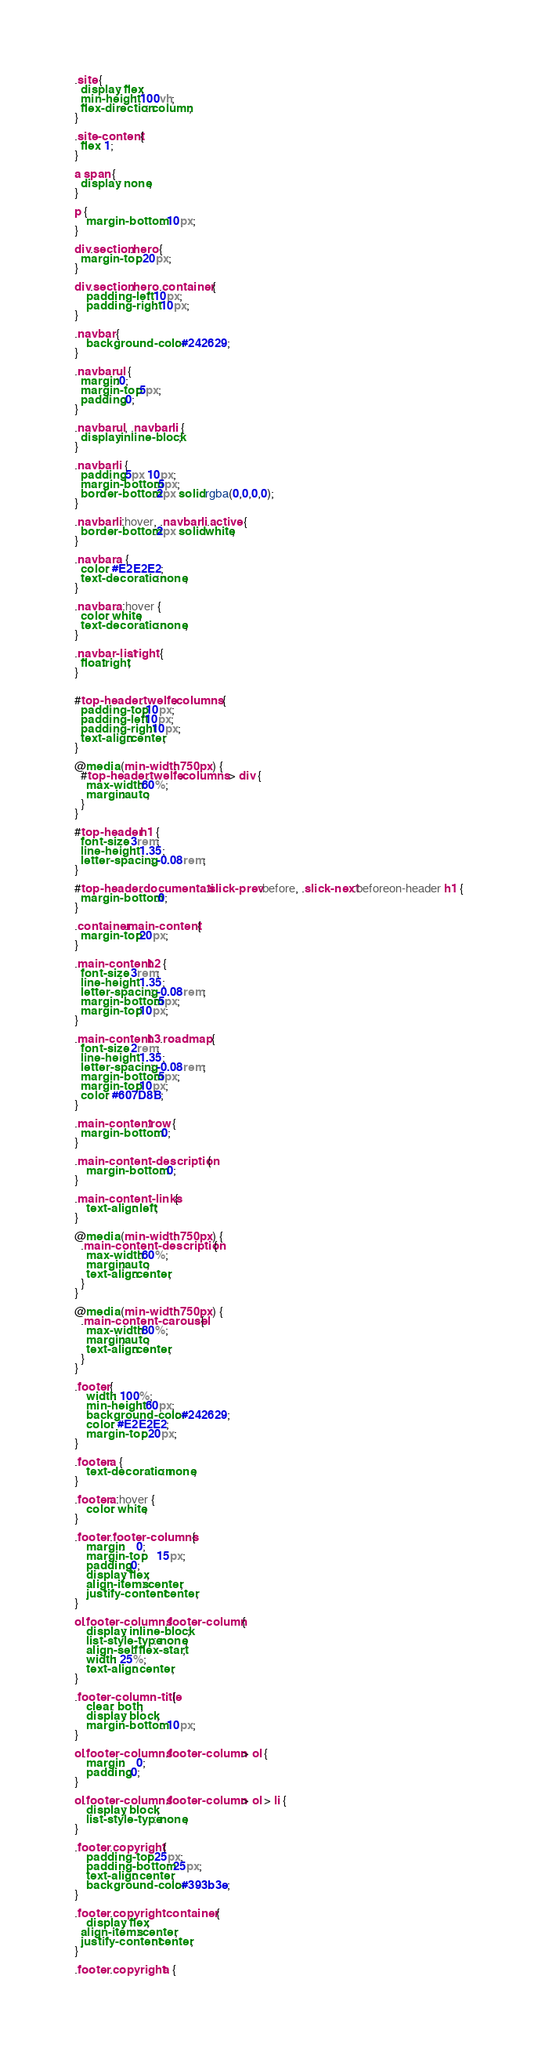<code> <loc_0><loc_0><loc_500><loc_500><_CSS_>.site {
  display: flex;
  min-height: 100vh;
  flex-direction: column;
}

.site-content {
  flex: 1;
}

a span {
  display: none;
}

p {
	margin-bottom: 10px;
}

div.section.hero {
  margin-top: 20px;
}

div.section.hero .container {
	padding-left: 10px;
	padding-right: 10px;
}

.navbar {
	background-color: #242629;
}

.navbar ul {
  margin:0;
  margin-top:5px;
  padding:0;
}

.navbar ul, .navbar li {
  display:inline-block;
}

.navbar li {
  padding:5px 10px;
  margin-bottom:5px;
  border-bottom:2px solid rgba(0,0,0,0);
}

.navbar li:hover, .navbar li.active {
  border-bottom:2px solid white;
}

.navbar a {
  color: #E2E2E2;
  text-decoration:none;
}

.navbar a:hover {
  color: white;
  text-decoration:none;
}

.navbar-list.right {
  float:right;
}


#top-header .twelfe.columns {
  padding-top:10px;
  padding-left:10px;
  padding-right:10px;
  text-align:center;
}

@media (min-width: 750px) {
  #top-header .twelfe.columns > div {
    max-width:60%;
    margin:auto;
  }
}

#top-header h1 {
  font-size: 3rem;
  line-height: 1.35;
  letter-spacing: -0.08rem;
}

#top-header .documentati.slick-prev:before, .slick-next:beforeon-header h1 {
  margin-bottom:0;
}

.container.main-content {
  margin-top:20px;
}

.main-content h2 {
  font-size: 3rem;
  line-height: 1.35;
  letter-spacing: -0.08rem;
  margin-bottom:5px;
  margin-top:10px;
}

.main-content h3.roadmap {
  font-size: 2rem;
  line-height: 1.35;
  letter-spacing: -0.08rem;
  margin-bottom:5px;
  margin-top:10px;
  color: #607D8B;
}

.main-content .row {
  margin-bottom: 0;
}

.main-content-description {
	margin-bottom: 0;
}

.main-content-links {
	text-align: left;
}

@media (min-width: 750px) { 
  .main-content-description {
    max-width:60%;
    margin:auto;
    text-align:center;
  }
}

@media (min-width: 750px) { 
  .main-content-carousel {
    max-width:80%;
    margin:auto;
    text-align:center;
  }
}

.footer {
	width: 100%;
	min-height: 60px;
	background-color: #242629;
	color: #E2E2E2;
	margin-top: 20px;
}

.footer a {
	text-decoration: none;
}

.footer a:hover {
	color: white;
}

.footer .footer-columns {
	margin:	0;
  	margin-top:	15px;
	padding:0;
	display: flex;
  	align-items: center;
  	justify-content: center;
}

ol.footer-columns .footer-column {
	display: inline-block;
	list-style-type: none;
	align-self: flex-start;
	width: 25%;
	text-align: center;
}

.footer-column-title {
	clear: both;
	display: block;
	margin-bottom: 10px;
}

ol.footer-columns .footer-column > ol {
	margin:	0;
	padding:0;
}

ol.footer-columns .footer-column > ol > li {
	display: block;
	list-style-type: none;
}

.footer .copyright {
	padding-top: 25px;
	padding-bottom: 25px;
	text-align: center;
	background-color: #393b3e;
}

.footer .copyright .container {
	display: flex;
  align-items: center;
  justify-content: center;
}

.footer .copyright a {</code> 